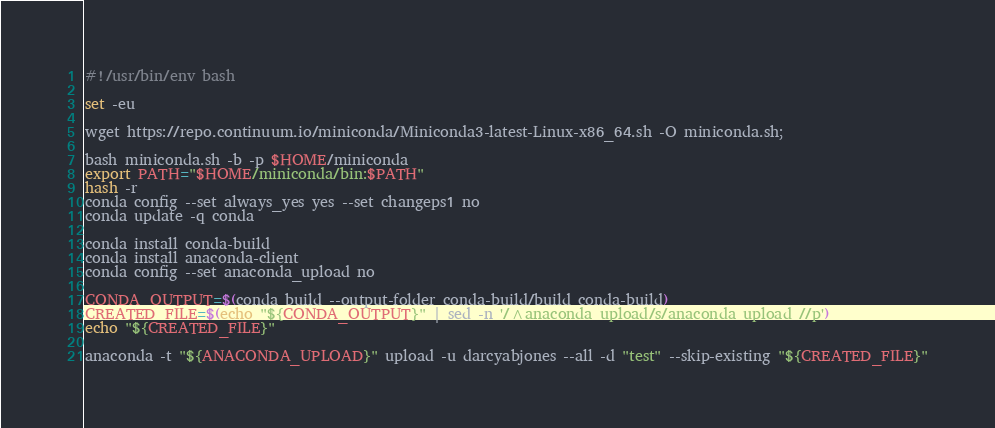<code> <loc_0><loc_0><loc_500><loc_500><_Bash_>#!/usr/bin/env bash

set -eu

wget https://repo.continuum.io/miniconda/Miniconda3-latest-Linux-x86_64.sh -O miniconda.sh;

bash miniconda.sh -b -p $HOME/miniconda
export PATH="$HOME/miniconda/bin:$PATH"
hash -r
conda config --set always_yes yes --set changeps1 no
conda update -q conda

conda install conda-build
conda install anaconda-client
conda config --set anaconda_upload no

CONDA_OUTPUT=$(conda build --output-folder conda-build/build conda-build)
CREATED_FILE=$(echo "${CONDA_OUTPUT}" | sed -n '/^anaconda upload/s/anaconda upload //p')
echo "${CREATED_FILE}"

anaconda -t "${ANACONDA_UPLOAD}" upload -u darcyabjones --all -d "test" --skip-existing "${CREATED_FILE}"
</code> 